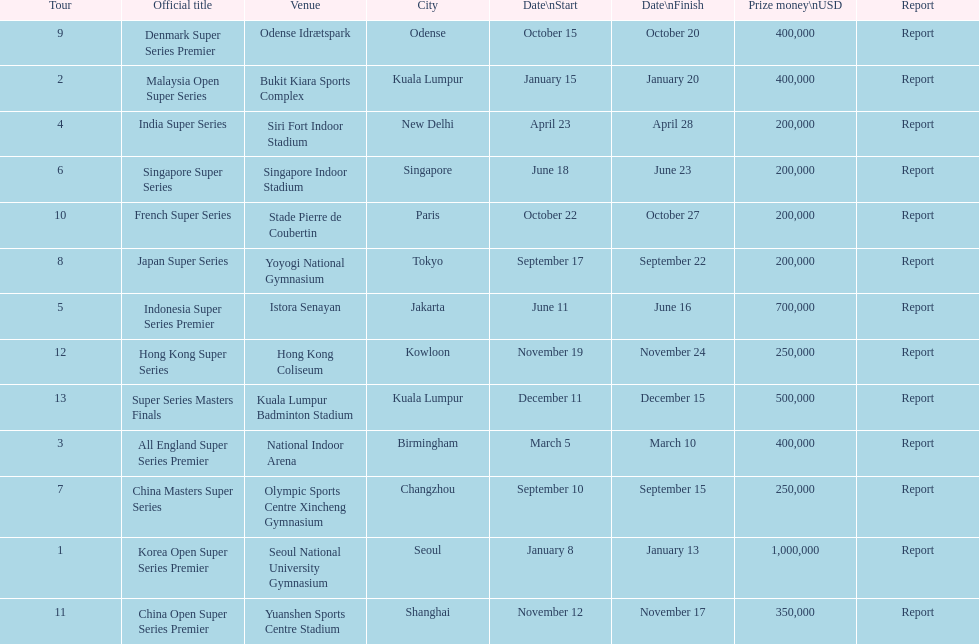Does the malaysia open super series pay more or less than french super series? More. 